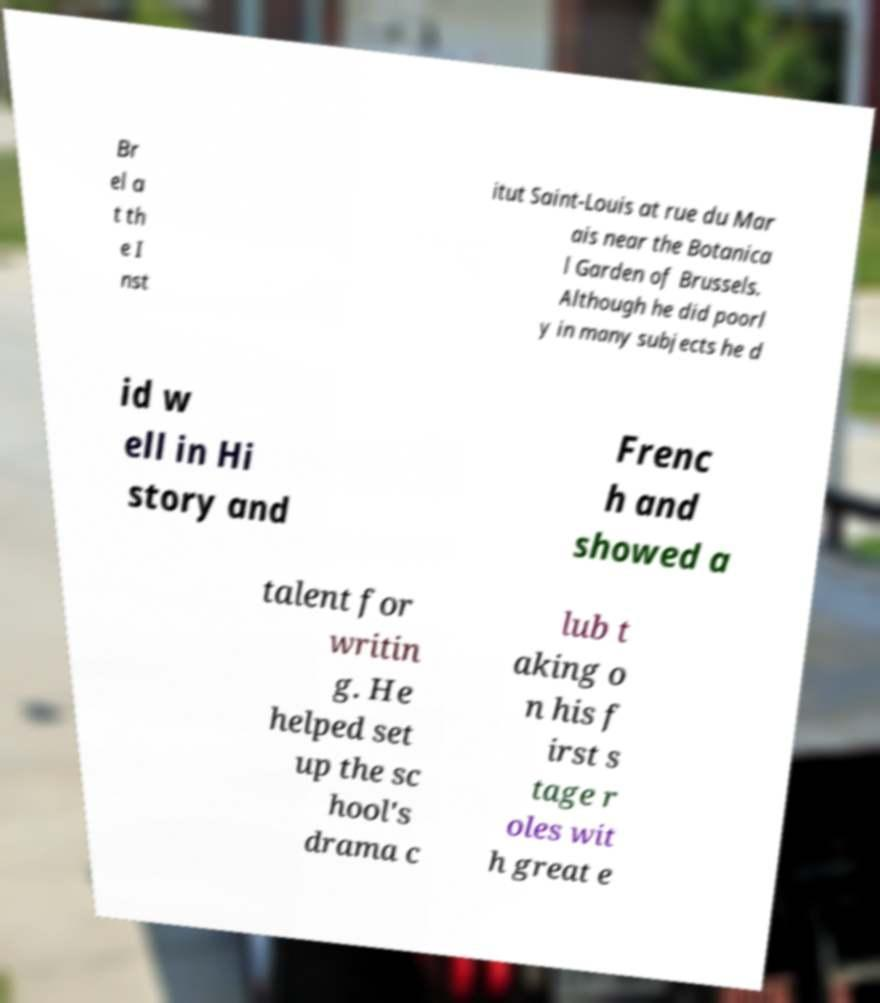I need the written content from this picture converted into text. Can you do that? Br el a t th e I nst itut Saint-Louis at rue du Mar ais near the Botanica l Garden of Brussels. Although he did poorl y in many subjects he d id w ell in Hi story and Frenc h and showed a talent for writin g. He helped set up the sc hool's drama c lub t aking o n his f irst s tage r oles wit h great e 